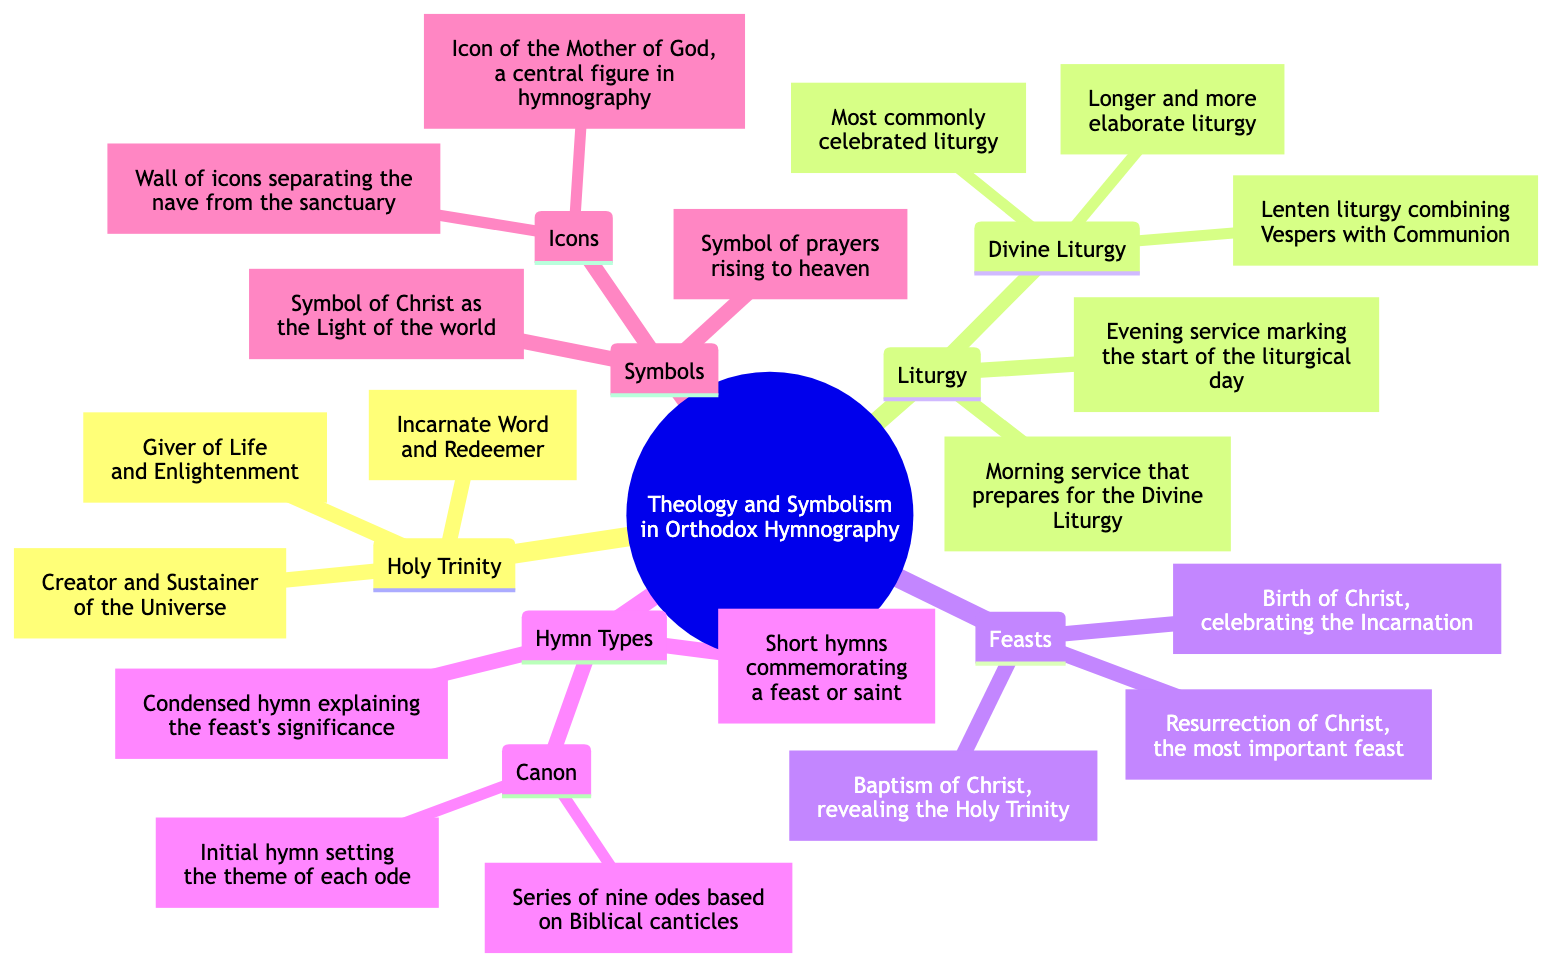What is the most important feast in Orthodox Theology? According to the diagram, the most important feast listed under Feasts is Pascha, which is described as the Resurrection of Christ.
Answer: Pascha What does the Father represent in the Holy Trinity? The diagram indicates that the Father symbolizes the Creator and Sustainer of the Universe in the Holy Trinity section.
Answer: Creator and Sustainer of the Universe How many types of hymns are mentioned in the Hymn Types section? The diagram lists three types of hymns: Troparion, Kontakion, and Canon. Hence, the total number is three.
Answer: 3 What does the icon of Theotokos symbolize in hymnography? The diagram specifies that the Theotokos, as an icon, is a central figure in hymnography, which implies her significance in the religious context.
Answer: A central figure in hymnography Which liturgy is the longest and most elaborate? From the diagram, St. Basil the Great is indicated as the longer and more elaborate liturgy compared to others.
Answer: St. Basil the Great What is the purpose of the Incense symbol? The diagram clearly states that Incense symbolizes prayers rising to heaven. This indicates its function within the liturgical context.
Answer: Symbol of prayers rising to heaven What is the initial hymn that sets the theme of each ode in a Canon? The diagram points out that the Irmos is the initial hymn that sets the theme for each ode within the Canon structure.
Answer: Irmos How is the Divine Liturgy described in the diagram? The diagram provides descriptions for different liturgies and states that the Divine Liturgy includes St. John Chrysostom as the most commonly celebrated liturgy.
Answer: Most commonly celebrated liturgy What does Light symbolize in Orthodox hymnography? The diagram defines Light as the symbol of Christ as the Light of the world, explaining its importance in Orthodox symbolism.
Answer: Symbol of Christ as the Light of the world 